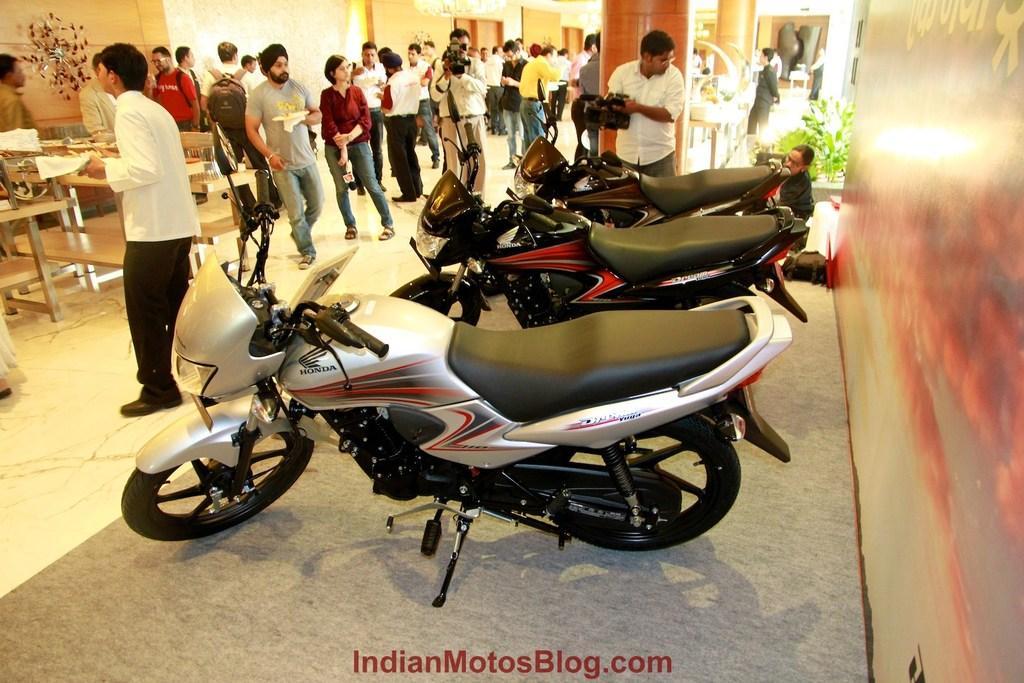How would you summarize this image in a sentence or two? In this image we can see a few people among them some are holding the objects, there are some motorbikes, pillars, plants and tables, on the right side of the image we can see the wall. 